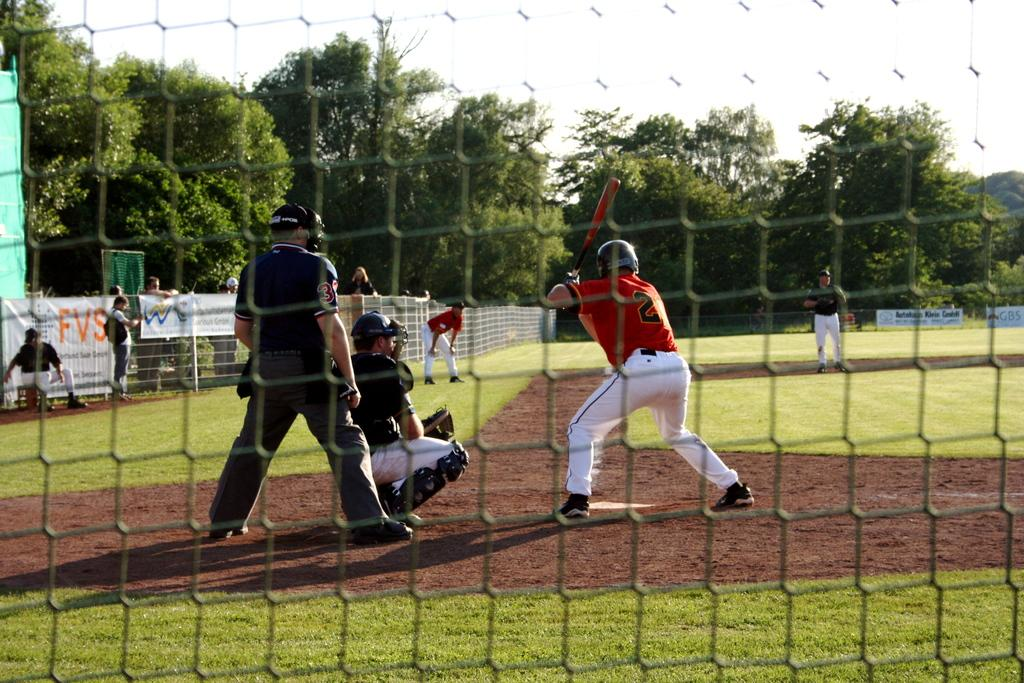<image>
Describe the image concisely. A baseball game is underway and a white sign on the fence says FVS. 